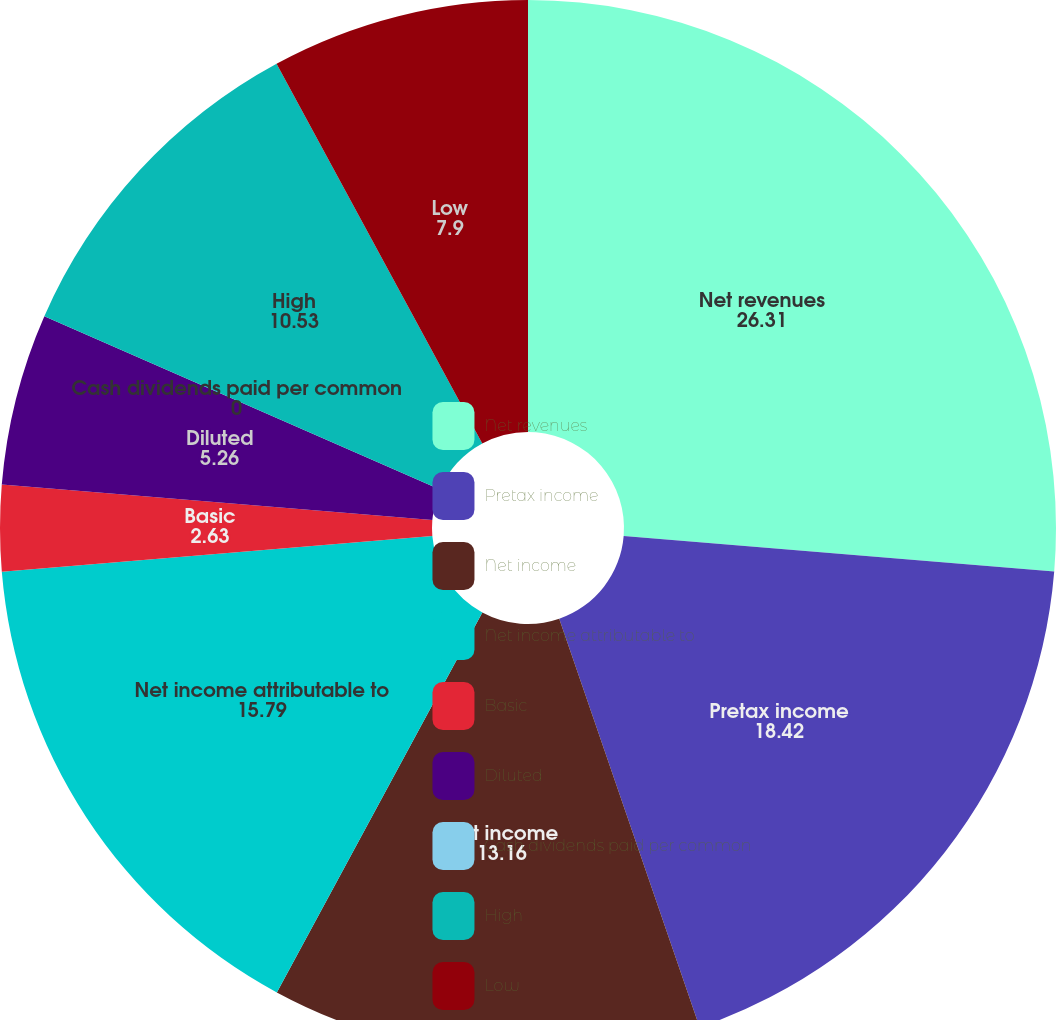Convert chart. <chart><loc_0><loc_0><loc_500><loc_500><pie_chart><fcel>Net revenues<fcel>Pretax income<fcel>Net income<fcel>Net income attributable to<fcel>Basic<fcel>Diluted<fcel>Cash dividends paid per common<fcel>High<fcel>Low<nl><fcel>26.31%<fcel>18.42%<fcel>13.16%<fcel>15.79%<fcel>2.63%<fcel>5.26%<fcel>0.0%<fcel>10.53%<fcel>7.9%<nl></chart> 